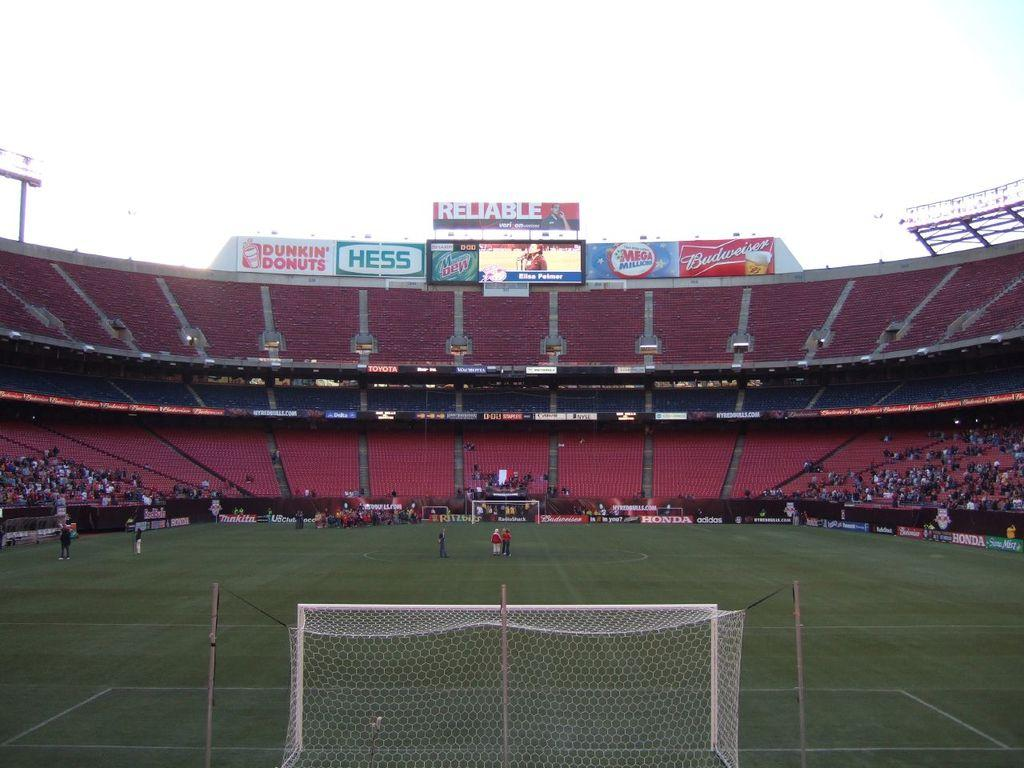<image>
Present a compact description of the photo's key features. A large stadium with advertisements placed at the top for Dunkin Donuts and Hess 